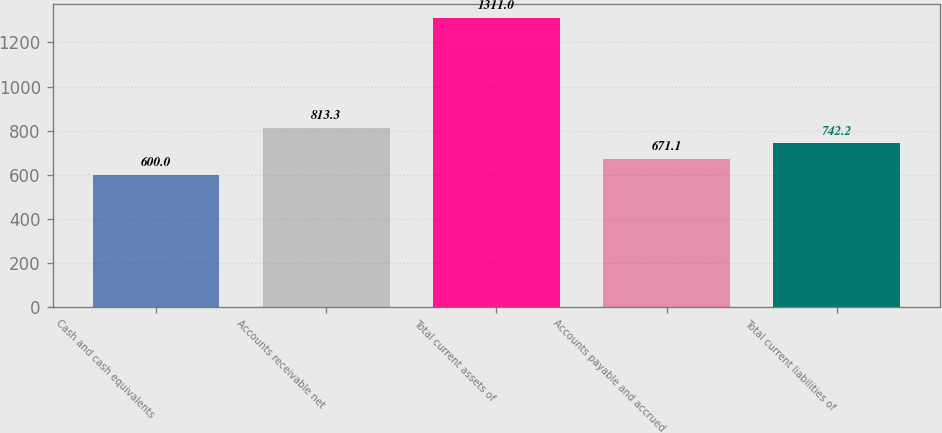Convert chart. <chart><loc_0><loc_0><loc_500><loc_500><bar_chart><fcel>Cash and cash equivalents<fcel>Accounts receivable net<fcel>Total current assets of<fcel>Accounts payable and accrued<fcel>Total current liabilities of<nl><fcel>600<fcel>813.3<fcel>1311<fcel>671.1<fcel>742.2<nl></chart> 